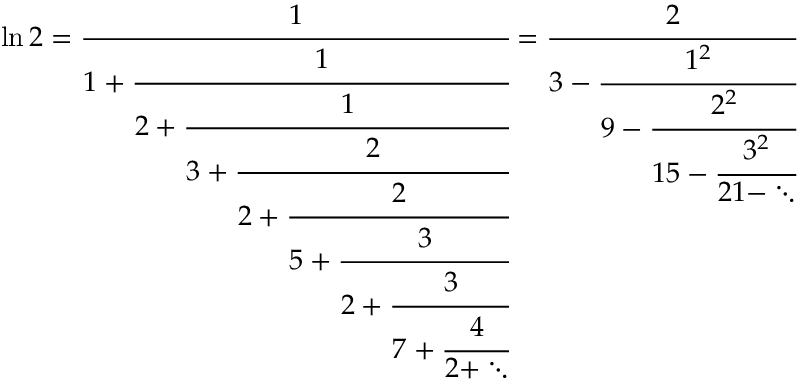Convert formula to latex. <formula><loc_0><loc_0><loc_500><loc_500>\ln 2 = { \cfrac { 1 } { 1 + { \cfrac { 1 } { 2 + { \cfrac { 1 } { 3 + { \cfrac { 2 } { 2 + { \cfrac { 2 } { 5 + { \cfrac { 3 } { 2 + { \cfrac { 3 } { 7 + { \cfrac { 4 } { 2 + \ddots } } } } } } } } } } } } } } } } = { \cfrac { 2 } { 3 - { \cfrac { 1 ^ { 2 } } { 9 - { \cfrac { 2 ^ { 2 } } { 1 5 - { \cfrac { 3 ^ { 2 } } { 2 1 - \ddots } } } } } } } }</formula> 